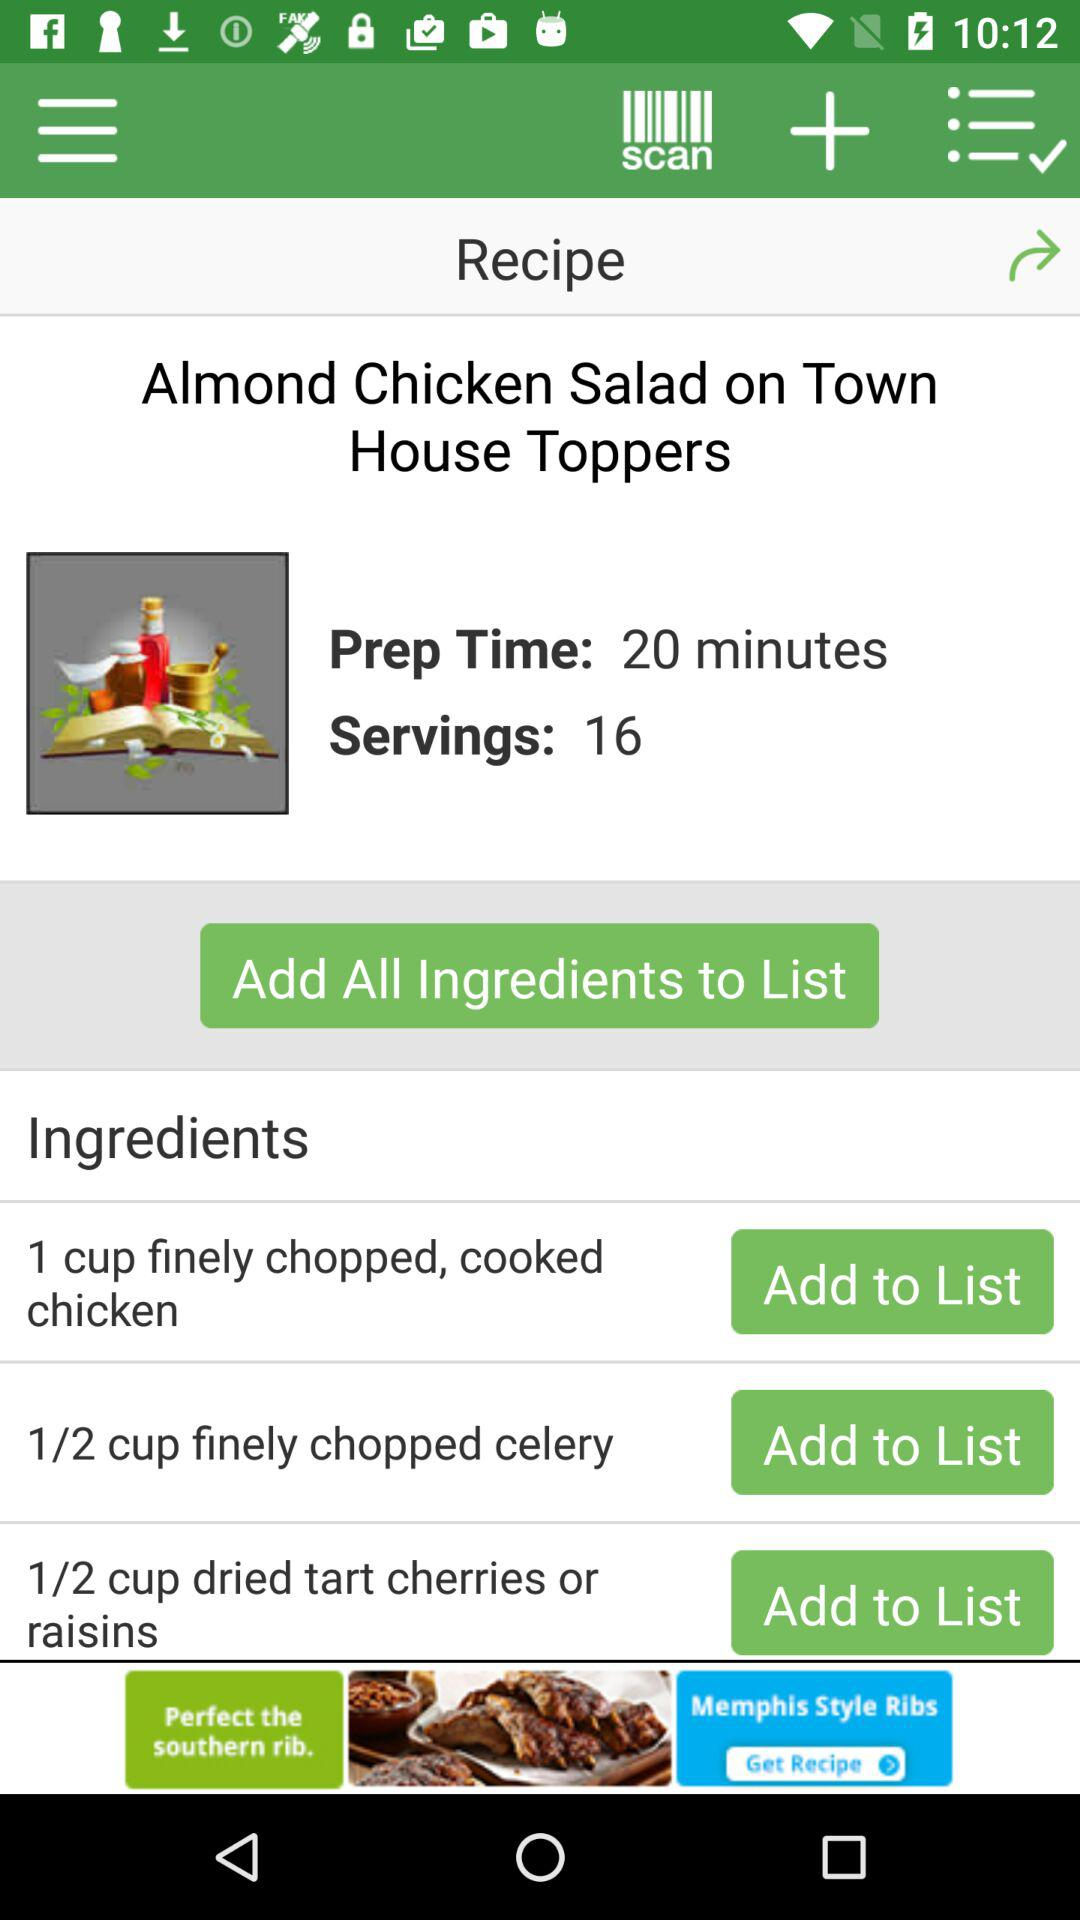What are the ingredients? The ingredients are 1 cup finely chopped cooked chicken, 1/2 cup finely chopped celery and 1/2 cup dried tart cherries or raisins. 